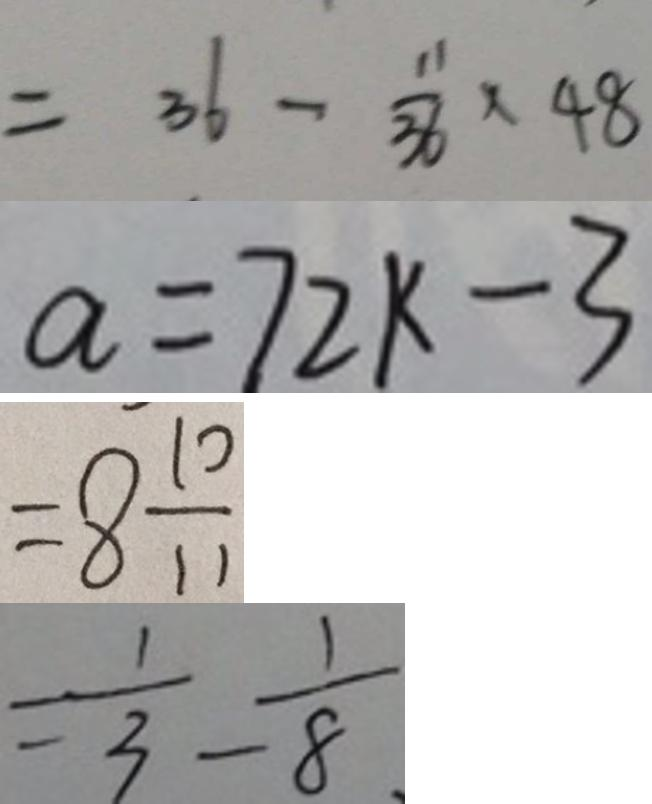<formula> <loc_0><loc_0><loc_500><loc_500>= 3 6 - \frac { 1 1 } { 3 6 } \times 4 8 
 a = 7 2 k - 3 
 = 8 \frac { 1 0 } { 1 1 } 
 = \frac { 1 } { 3 } - \frac { 1 } { 8 }</formula> 